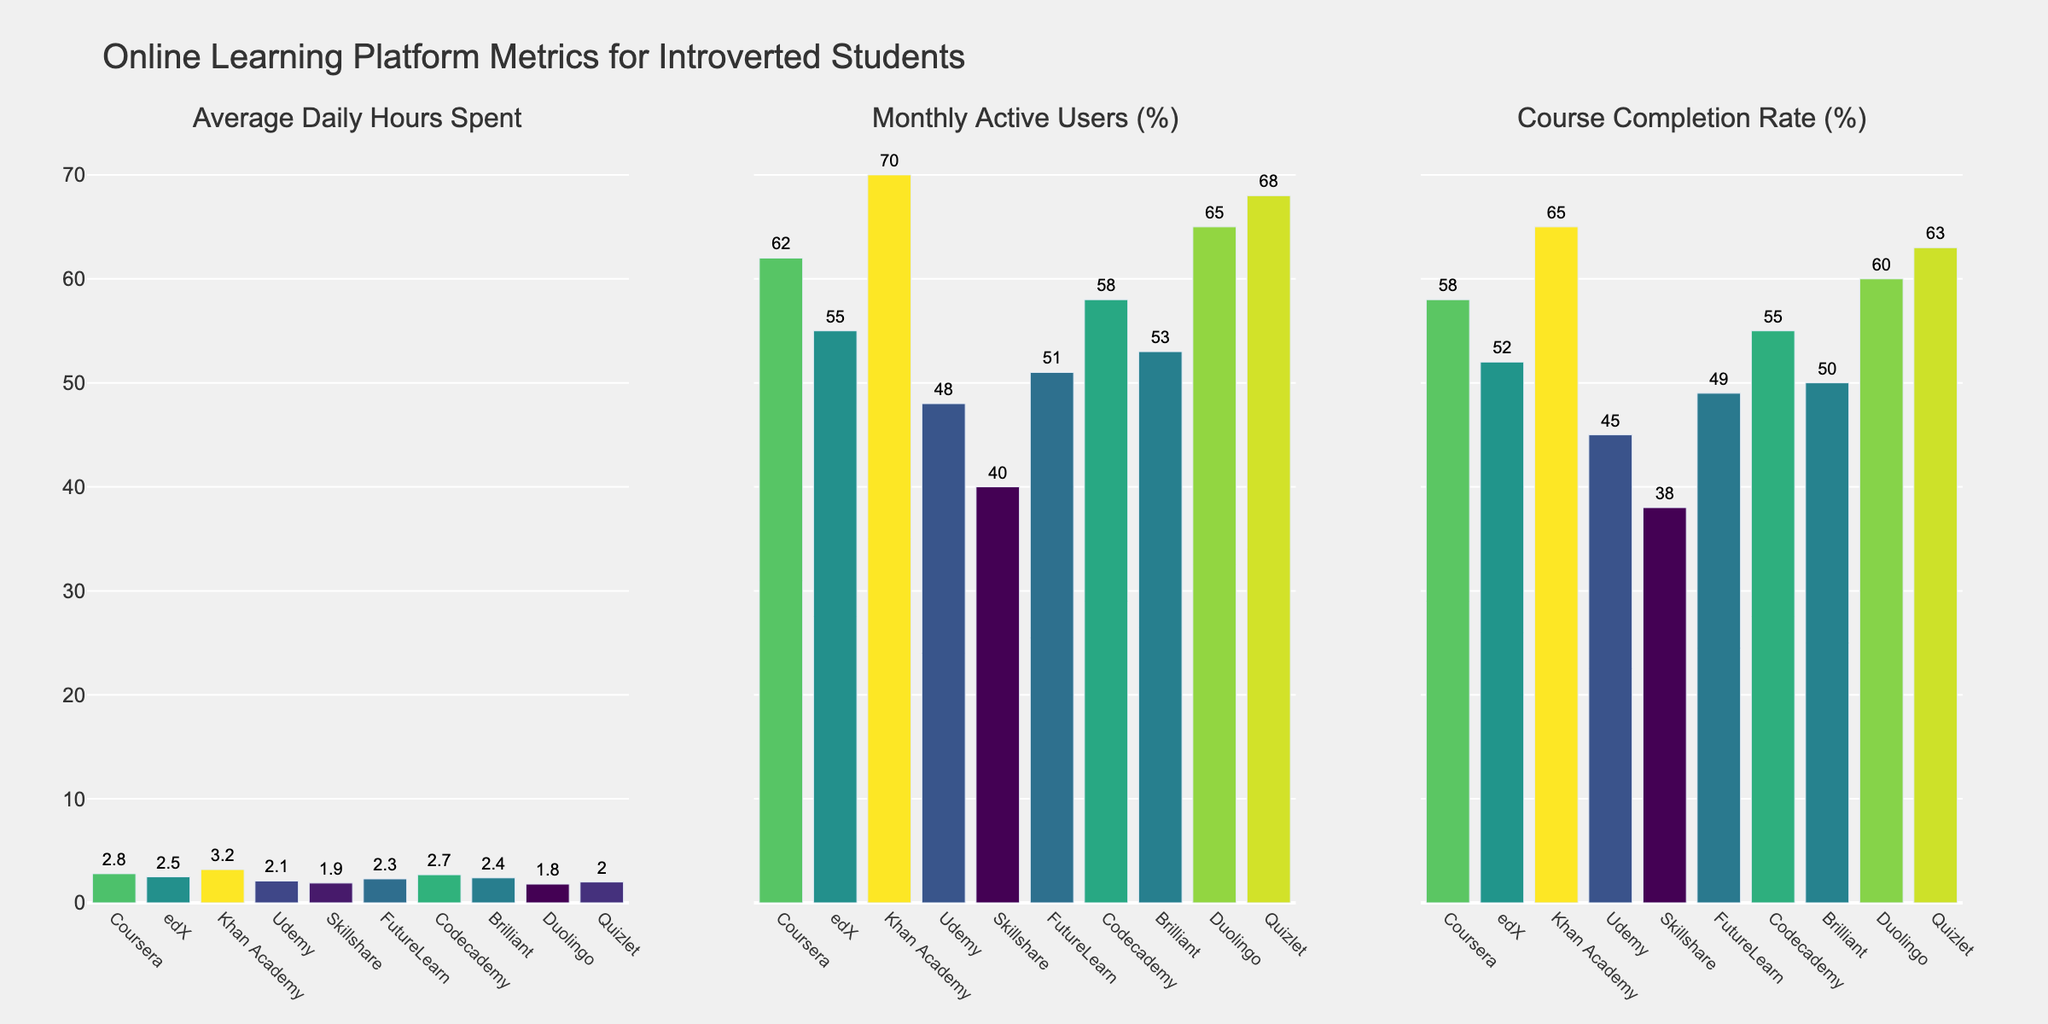What's the average daily hours spent on Khan Academy? Look at the bar corresponding to Khan Academy in the "Average Daily Hours Spent" subplot. The value is shown at the top of the bar.
Answer: 3.2 Which platform has the highest completion rate? In the "Course Completion Rate (%)" subplot, identify the tallest bar. The platform with the tallest bar is Khan Academy.
Answer: Khan Academy How many more percentage points are Khan Academy's Monthly Active Users compared to Udemy's? Find the values for Khan Academy and Udemy in the "Monthly Active Users (%)" subplot. Subtract Udemy's value from Khan Academy's value: 70% - 48% = 22%.
Answer: 22% Which platform has the lowest average daily hours spent? Identify the shortest bar in the "Average Daily Hours Spent" subplot. The shortest bar corresponds to Duolingo.
Answer: Duolingo Rank the top three platforms by average daily hours spent from highest to lowest. Compare the heights of the bars in the "Average Daily Hours Spent" subplot. The top three are Khan Academy (3.2), Coursera (2.8), and Codecademy (2.7).
Answer: Khan Academy, Coursera, Codecademy What is the difference between the completion rates of Codecademy and Skillshare? Find the values for Codecademy and Skillshare in the "Course Completion Rate (%)" subplot. Subtract Skillshare's value from Codecademy's value: 55% - 38% = 17%.
Answer: 17% Which platform has the second highest monthly active users percentage? In the "Monthly Active Users (%)" subplot, identify the second tallest bar. The second tallest bar corresponds to Quizlet.
Answer: Quizlet What is the total average daily hours spent on Coursera, edX, and FutureLearn? Find the values for Coursera, edX, and FutureLearn in the "Average Daily Hours Spent" subplot. Add these values together: 2.8 + 2.5 + 2.3 = 7.6.
Answer: 7.6 Is the course completion rate for Duolingo higher or lower than for Brilliant? Compare the bar heights for Duolingo and Brilliant in the "Course Completion Rate (%)" subplot. Duolingo's completion rate (60%) is higher than Brilliant's (50%).
Answer: Higher List the platforms with a monthly active user percentage above 60%. Identify bars in the "Monthly Active Users (%)" subplot with values above 60%. These platforms are Coursera, Khan Academy, and Duolingo.
Answer: Coursera, Khan Academy, Duolingo 